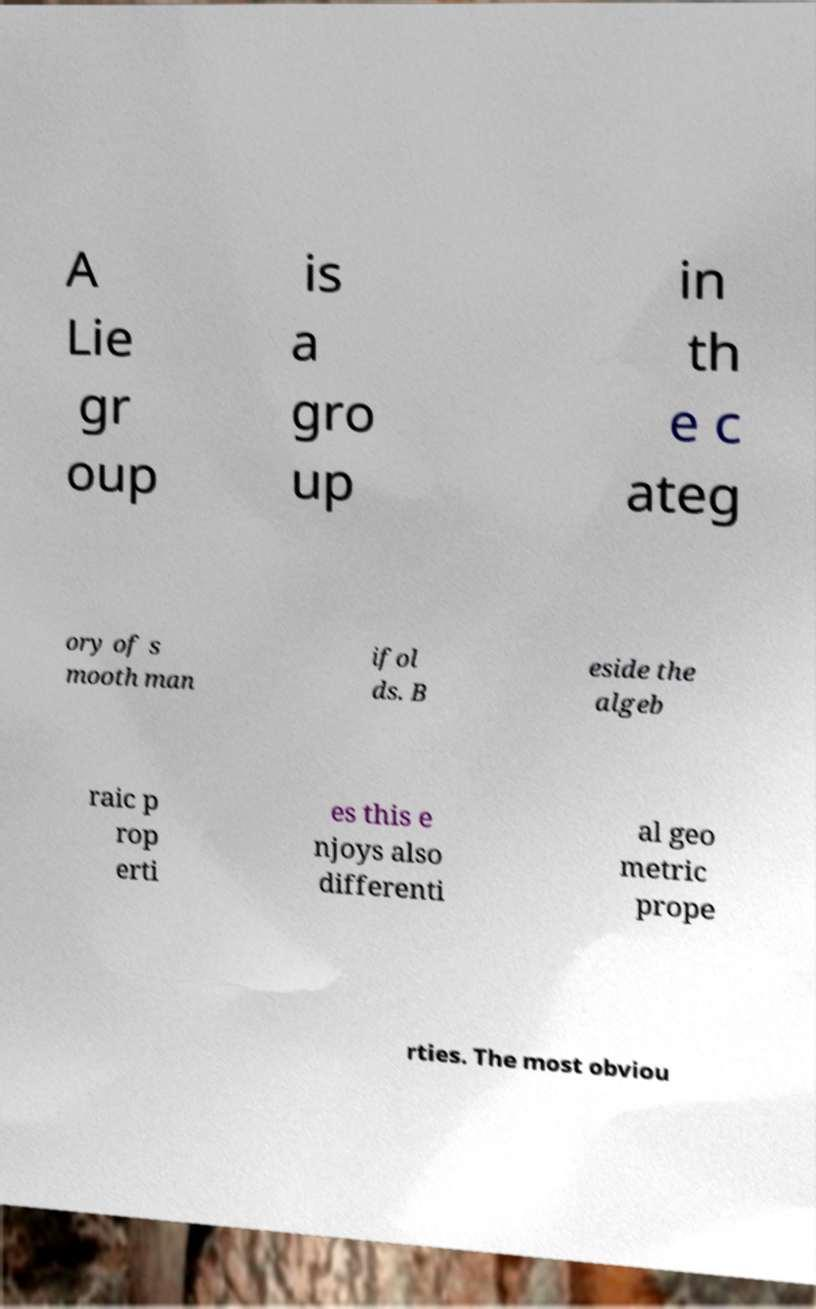There's text embedded in this image that I need extracted. Can you transcribe it verbatim? A Lie gr oup is a gro up in th e c ateg ory of s mooth man ifol ds. B eside the algeb raic p rop erti es this e njoys also differenti al geo metric prope rties. The most obviou 